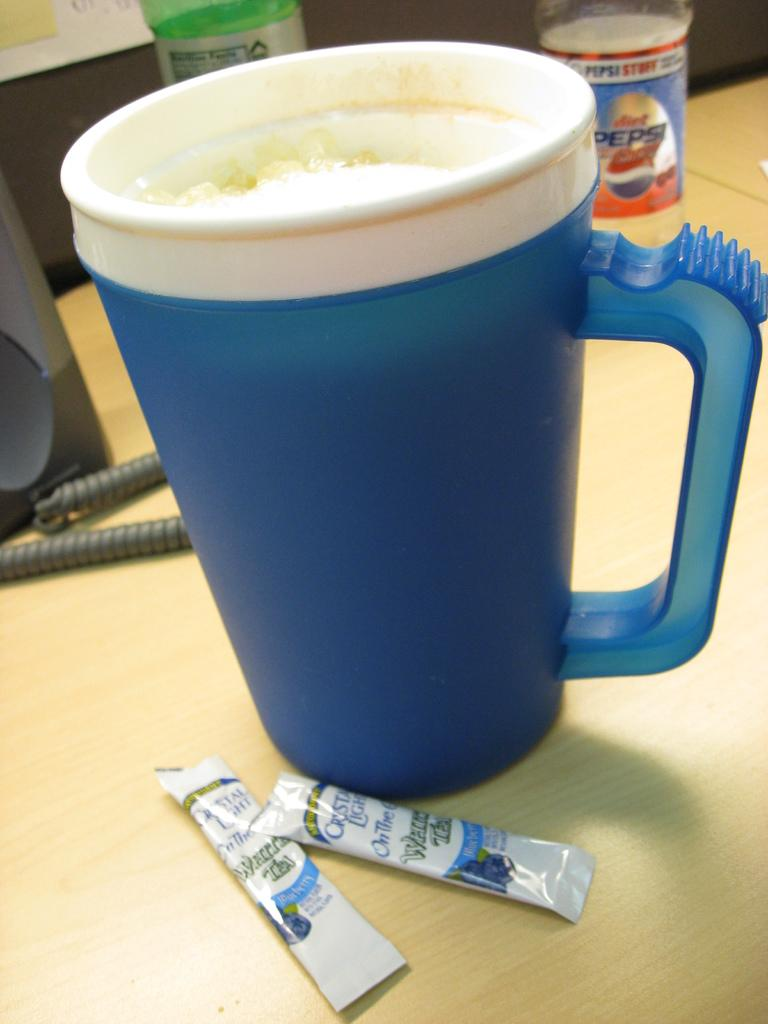What type of furniture is present in the image? There is a table in the image. What color is the table? The table is yellow. What is placed on the table? There is a cup on the table. What color is the cup? The cup is blue. Are there any white objects on the table? Yes, there are objects on the table that are white. What type of wood is the scarecrow made of in the image? There is no scarecrow present in the image; it only features a yellow table and a blue cup. 